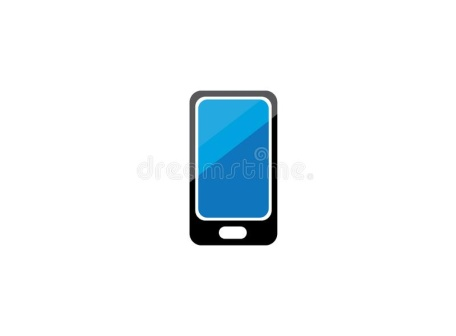Imagine this phone is part of a spy gadget kit. Describe its features in this context. As part of a spy gadget kit, this phone could be an essential tool with a range of covert features. It might include a fingerprint-resistant coating to avoid leaving traces. The screen, while appearing normal, could switch to invisibility mode, allowing spies to send secret messages without writing anything visible. An enhanced microphone with noise-cancellation technology would enable crystal-clear audio recording, even in crowded or noisy environments. The camera could have night vision and thermal imaging capabilities. Additionally, built-in decryption software would allow the user to intercept and decode encrypted messages. For secure communications, the phone might have quantum encryption, making it virtually unhackable. 